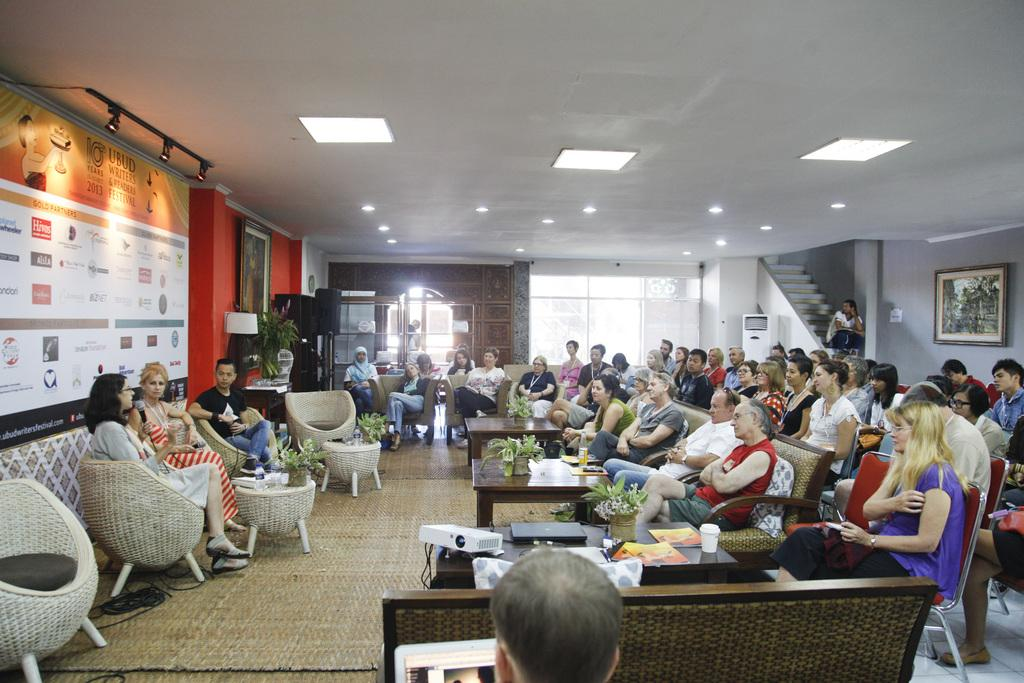What are the people in the image doing? There is a group of people sitting in chairs. What can be seen in the background of the image? In the background, there is a hoarding, lights, chairs, plants, a table, a staircase, an air conditioner, and a frame. Can you describe the setting where the people are sitting? The people are sitting in chairs in a room with a background that includes various objects and features. What type of quilt is being used by the committee in the image? There is no mention of a quilt or a committee in the image. 